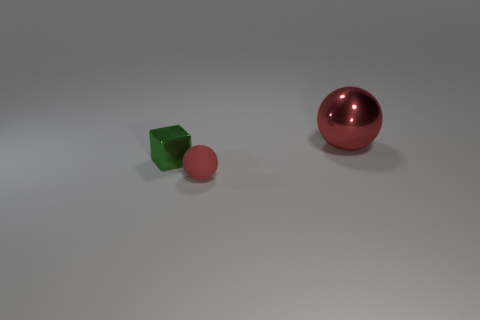There is a metal thing that is to the left of the tiny red ball; is it the same size as the red sphere that is to the left of the big red shiny object?
Your response must be concise. Yes. There is a tiny green cube behind the sphere that is on the left side of the big ball; what is it made of?
Your answer should be very brief. Metal. Is the number of tiny green things that are to the right of the big shiny ball less than the number of big red shiny objects?
Provide a short and direct response. Yes. What is the shape of the green object that is made of the same material as the big sphere?
Make the answer very short. Cube. What number of other objects are the same shape as the green object?
Offer a very short reply. 0. What number of yellow objects are rubber things or shiny cubes?
Provide a succinct answer. 0. Do the large red metal object and the tiny red object have the same shape?
Your answer should be compact. Yes. Are there any big metal things that are to the right of the red sphere that is to the left of the big object?
Your response must be concise. Yes. Are there the same number of small balls that are right of the tiny rubber ball and yellow shiny spheres?
Offer a terse response. Yes. What number of other things are the same size as the green metal object?
Your answer should be compact. 1. 